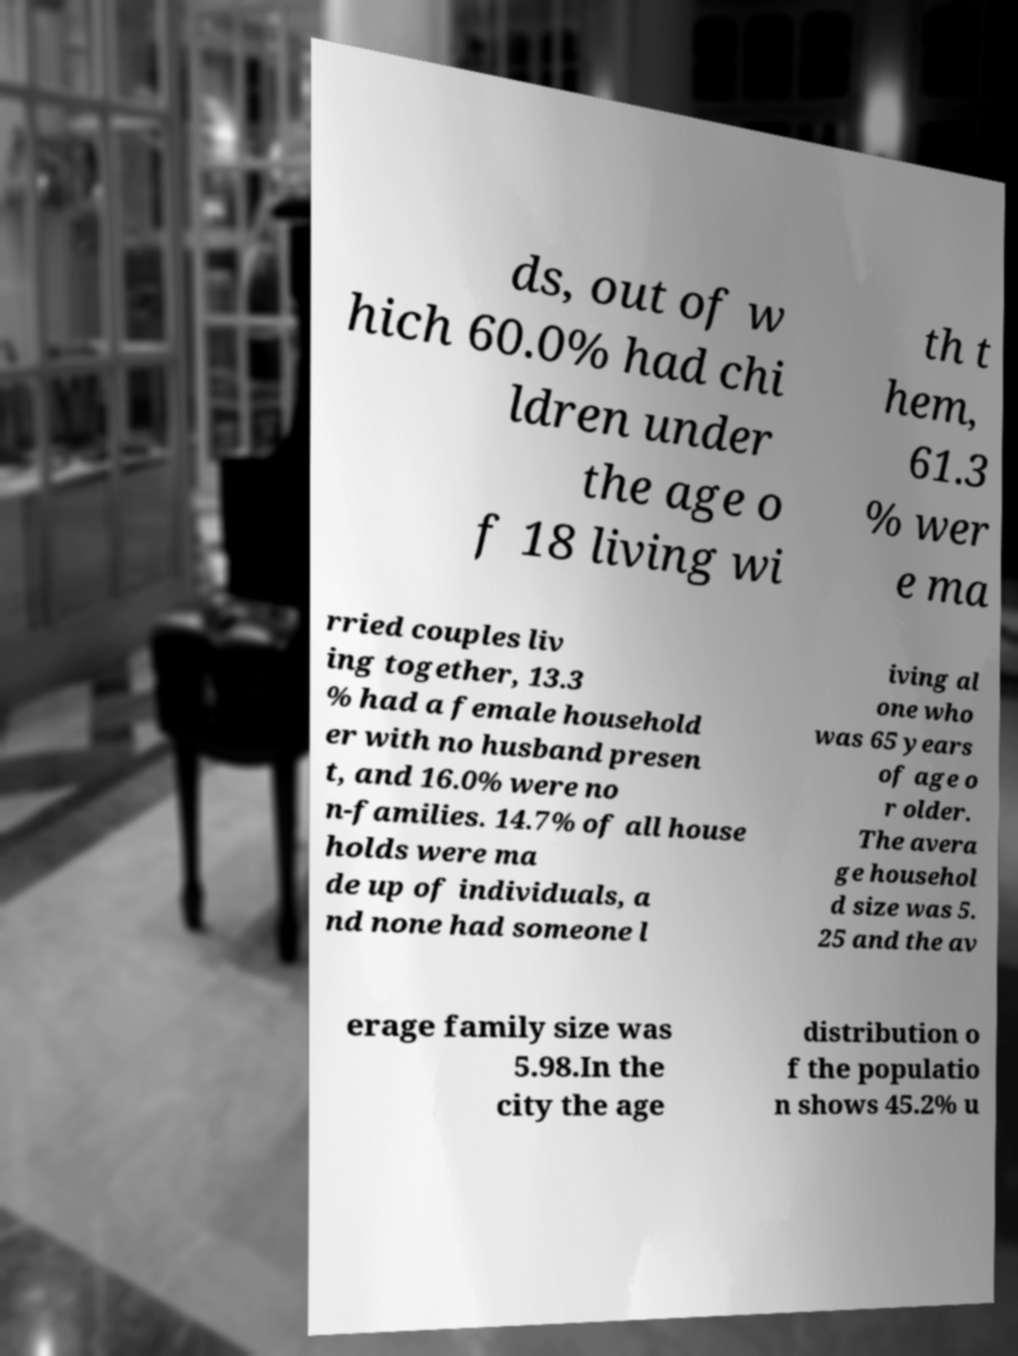For documentation purposes, I need the text within this image transcribed. Could you provide that? ds, out of w hich 60.0% had chi ldren under the age o f 18 living wi th t hem, 61.3 % wer e ma rried couples liv ing together, 13.3 % had a female household er with no husband presen t, and 16.0% were no n-families. 14.7% of all house holds were ma de up of individuals, a nd none had someone l iving al one who was 65 years of age o r older. The avera ge househol d size was 5. 25 and the av erage family size was 5.98.In the city the age distribution o f the populatio n shows 45.2% u 